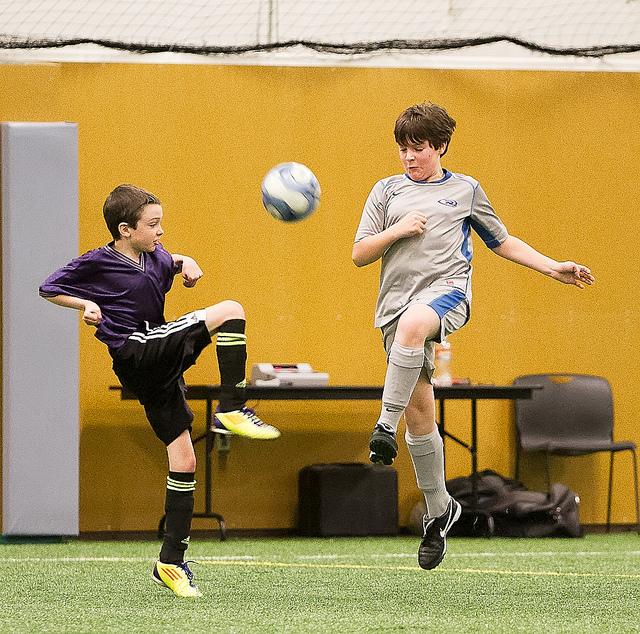Are these boys the same age?
Give a very brief answer. No. Are they playing soccer indoors?
Write a very short answer. Yes. Are these boys on the same team?
Keep it brief. No. 